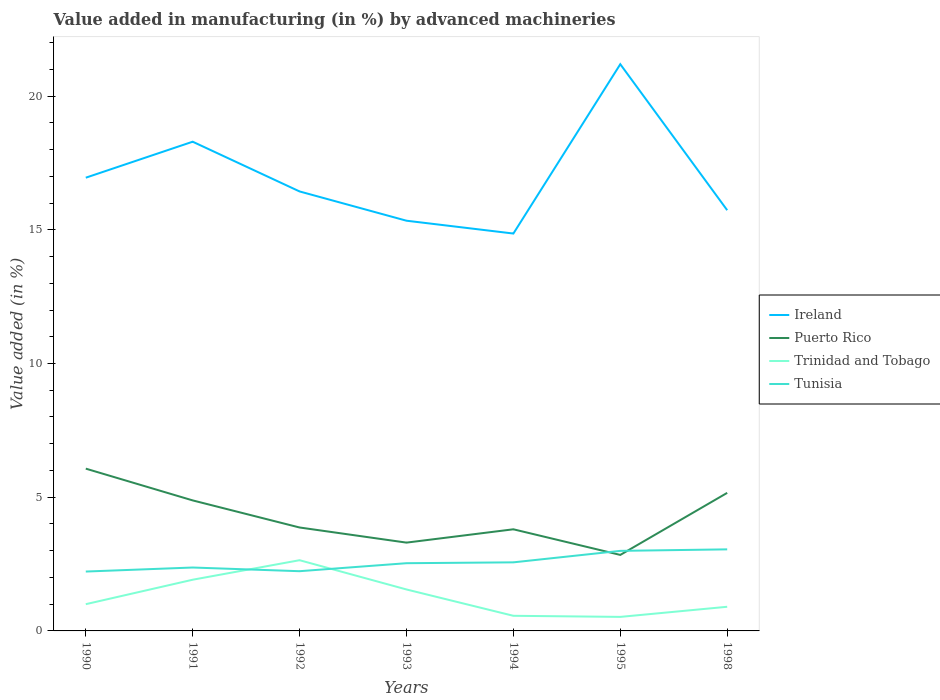Does the line corresponding to Puerto Rico intersect with the line corresponding to Tunisia?
Your response must be concise. Yes. Across all years, what is the maximum percentage of value added in manufacturing by advanced machineries in Trinidad and Tobago?
Offer a very short reply. 0.52. What is the total percentage of value added in manufacturing by advanced machineries in Trinidad and Tobago in the graph?
Your response must be concise. 0.48. What is the difference between the highest and the second highest percentage of value added in manufacturing by advanced machineries in Puerto Rico?
Your answer should be compact. 3.23. Where does the legend appear in the graph?
Your answer should be very brief. Center right. How are the legend labels stacked?
Your answer should be compact. Vertical. What is the title of the graph?
Your response must be concise. Value added in manufacturing (in %) by advanced machineries. Does "Brazil" appear as one of the legend labels in the graph?
Your answer should be compact. No. What is the label or title of the X-axis?
Offer a terse response. Years. What is the label or title of the Y-axis?
Make the answer very short. Value added (in %). What is the Value added (in %) of Ireland in 1990?
Offer a very short reply. 16.95. What is the Value added (in %) of Puerto Rico in 1990?
Make the answer very short. 6.07. What is the Value added (in %) of Trinidad and Tobago in 1990?
Your answer should be very brief. 1. What is the Value added (in %) of Tunisia in 1990?
Give a very brief answer. 2.22. What is the Value added (in %) in Ireland in 1991?
Your answer should be compact. 18.29. What is the Value added (in %) of Puerto Rico in 1991?
Ensure brevity in your answer.  4.88. What is the Value added (in %) in Trinidad and Tobago in 1991?
Keep it short and to the point. 1.91. What is the Value added (in %) in Tunisia in 1991?
Keep it short and to the point. 2.37. What is the Value added (in %) of Ireland in 1992?
Offer a very short reply. 16.43. What is the Value added (in %) of Puerto Rico in 1992?
Offer a terse response. 3.87. What is the Value added (in %) of Trinidad and Tobago in 1992?
Make the answer very short. 2.64. What is the Value added (in %) of Tunisia in 1992?
Your response must be concise. 2.23. What is the Value added (in %) of Ireland in 1993?
Give a very brief answer. 15.34. What is the Value added (in %) in Puerto Rico in 1993?
Ensure brevity in your answer.  3.3. What is the Value added (in %) in Trinidad and Tobago in 1993?
Ensure brevity in your answer.  1.55. What is the Value added (in %) of Tunisia in 1993?
Provide a short and direct response. 2.53. What is the Value added (in %) in Ireland in 1994?
Your response must be concise. 14.86. What is the Value added (in %) of Puerto Rico in 1994?
Your answer should be very brief. 3.8. What is the Value added (in %) in Trinidad and Tobago in 1994?
Provide a succinct answer. 0.57. What is the Value added (in %) in Tunisia in 1994?
Your answer should be very brief. 2.56. What is the Value added (in %) of Ireland in 1995?
Ensure brevity in your answer.  21.19. What is the Value added (in %) of Puerto Rico in 1995?
Keep it short and to the point. 2.84. What is the Value added (in %) in Trinidad and Tobago in 1995?
Keep it short and to the point. 0.52. What is the Value added (in %) in Tunisia in 1995?
Offer a terse response. 2.99. What is the Value added (in %) in Ireland in 1998?
Your response must be concise. 15.73. What is the Value added (in %) of Puerto Rico in 1998?
Give a very brief answer. 5.16. What is the Value added (in %) in Trinidad and Tobago in 1998?
Give a very brief answer. 0.9. What is the Value added (in %) of Tunisia in 1998?
Offer a very short reply. 3.05. Across all years, what is the maximum Value added (in %) in Ireland?
Your response must be concise. 21.19. Across all years, what is the maximum Value added (in %) of Puerto Rico?
Ensure brevity in your answer.  6.07. Across all years, what is the maximum Value added (in %) of Trinidad and Tobago?
Offer a terse response. 2.64. Across all years, what is the maximum Value added (in %) in Tunisia?
Offer a terse response. 3.05. Across all years, what is the minimum Value added (in %) in Ireland?
Ensure brevity in your answer.  14.86. Across all years, what is the minimum Value added (in %) in Puerto Rico?
Your response must be concise. 2.84. Across all years, what is the minimum Value added (in %) in Trinidad and Tobago?
Your answer should be compact. 0.52. Across all years, what is the minimum Value added (in %) of Tunisia?
Offer a terse response. 2.22. What is the total Value added (in %) of Ireland in the graph?
Give a very brief answer. 118.79. What is the total Value added (in %) in Puerto Rico in the graph?
Your answer should be very brief. 29.92. What is the total Value added (in %) in Trinidad and Tobago in the graph?
Ensure brevity in your answer.  9.1. What is the total Value added (in %) in Tunisia in the graph?
Your response must be concise. 17.96. What is the difference between the Value added (in %) of Ireland in 1990 and that in 1991?
Offer a very short reply. -1.35. What is the difference between the Value added (in %) in Puerto Rico in 1990 and that in 1991?
Your answer should be compact. 1.19. What is the difference between the Value added (in %) of Trinidad and Tobago in 1990 and that in 1991?
Keep it short and to the point. -0.91. What is the difference between the Value added (in %) in Tunisia in 1990 and that in 1991?
Give a very brief answer. -0.15. What is the difference between the Value added (in %) of Ireland in 1990 and that in 1992?
Make the answer very short. 0.51. What is the difference between the Value added (in %) in Puerto Rico in 1990 and that in 1992?
Your answer should be compact. 2.2. What is the difference between the Value added (in %) in Trinidad and Tobago in 1990 and that in 1992?
Offer a terse response. -1.64. What is the difference between the Value added (in %) in Tunisia in 1990 and that in 1992?
Give a very brief answer. -0.01. What is the difference between the Value added (in %) in Ireland in 1990 and that in 1993?
Offer a very short reply. 1.61. What is the difference between the Value added (in %) in Puerto Rico in 1990 and that in 1993?
Offer a very short reply. 2.77. What is the difference between the Value added (in %) in Trinidad and Tobago in 1990 and that in 1993?
Provide a short and direct response. -0.55. What is the difference between the Value added (in %) of Tunisia in 1990 and that in 1993?
Offer a terse response. -0.31. What is the difference between the Value added (in %) of Ireland in 1990 and that in 1994?
Give a very brief answer. 2.09. What is the difference between the Value added (in %) in Puerto Rico in 1990 and that in 1994?
Your answer should be compact. 2.27. What is the difference between the Value added (in %) in Trinidad and Tobago in 1990 and that in 1994?
Offer a terse response. 0.43. What is the difference between the Value added (in %) of Tunisia in 1990 and that in 1994?
Offer a terse response. -0.34. What is the difference between the Value added (in %) of Ireland in 1990 and that in 1995?
Give a very brief answer. -4.24. What is the difference between the Value added (in %) of Puerto Rico in 1990 and that in 1995?
Your response must be concise. 3.23. What is the difference between the Value added (in %) of Trinidad and Tobago in 1990 and that in 1995?
Ensure brevity in your answer.  0.48. What is the difference between the Value added (in %) in Tunisia in 1990 and that in 1995?
Give a very brief answer. -0.77. What is the difference between the Value added (in %) of Ireland in 1990 and that in 1998?
Ensure brevity in your answer.  1.22. What is the difference between the Value added (in %) in Puerto Rico in 1990 and that in 1998?
Your response must be concise. 0.91. What is the difference between the Value added (in %) of Trinidad and Tobago in 1990 and that in 1998?
Your answer should be compact. 0.1. What is the difference between the Value added (in %) in Tunisia in 1990 and that in 1998?
Offer a terse response. -0.83. What is the difference between the Value added (in %) in Ireland in 1991 and that in 1992?
Make the answer very short. 1.86. What is the difference between the Value added (in %) in Puerto Rico in 1991 and that in 1992?
Provide a short and direct response. 1.01. What is the difference between the Value added (in %) of Trinidad and Tobago in 1991 and that in 1992?
Provide a short and direct response. -0.73. What is the difference between the Value added (in %) of Tunisia in 1991 and that in 1992?
Provide a short and direct response. 0.14. What is the difference between the Value added (in %) in Ireland in 1991 and that in 1993?
Your answer should be compact. 2.95. What is the difference between the Value added (in %) of Puerto Rico in 1991 and that in 1993?
Keep it short and to the point. 1.58. What is the difference between the Value added (in %) in Trinidad and Tobago in 1991 and that in 1993?
Keep it short and to the point. 0.36. What is the difference between the Value added (in %) of Tunisia in 1991 and that in 1993?
Keep it short and to the point. -0.16. What is the difference between the Value added (in %) of Ireland in 1991 and that in 1994?
Your response must be concise. 3.43. What is the difference between the Value added (in %) in Puerto Rico in 1991 and that in 1994?
Ensure brevity in your answer.  1.08. What is the difference between the Value added (in %) in Trinidad and Tobago in 1991 and that in 1994?
Keep it short and to the point. 1.35. What is the difference between the Value added (in %) of Tunisia in 1991 and that in 1994?
Offer a terse response. -0.19. What is the difference between the Value added (in %) of Ireland in 1991 and that in 1995?
Your response must be concise. -2.9. What is the difference between the Value added (in %) of Puerto Rico in 1991 and that in 1995?
Provide a succinct answer. 2.04. What is the difference between the Value added (in %) in Trinidad and Tobago in 1991 and that in 1995?
Make the answer very short. 1.39. What is the difference between the Value added (in %) in Tunisia in 1991 and that in 1995?
Provide a succinct answer. -0.62. What is the difference between the Value added (in %) in Ireland in 1991 and that in 1998?
Your answer should be compact. 2.56. What is the difference between the Value added (in %) in Puerto Rico in 1991 and that in 1998?
Your answer should be very brief. -0.28. What is the difference between the Value added (in %) in Trinidad and Tobago in 1991 and that in 1998?
Give a very brief answer. 1.01. What is the difference between the Value added (in %) of Tunisia in 1991 and that in 1998?
Provide a succinct answer. -0.68. What is the difference between the Value added (in %) of Ireland in 1992 and that in 1993?
Make the answer very short. 1.09. What is the difference between the Value added (in %) in Puerto Rico in 1992 and that in 1993?
Provide a short and direct response. 0.57. What is the difference between the Value added (in %) in Trinidad and Tobago in 1992 and that in 1993?
Offer a terse response. 1.09. What is the difference between the Value added (in %) of Tunisia in 1992 and that in 1993?
Give a very brief answer. -0.3. What is the difference between the Value added (in %) in Ireland in 1992 and that in 1994?
Your answer should be compact. 1.57. What is the difference between the Value added (in %) of Puerto Rico in 1992 and that in 1994?
Your answer should be compact. 0.07. What is the difference between the Value added (in %) in Trinidad and Tobago in 1992 and that in 1994?
Make the answer very short. 2.08. What is the difference between the Value added (in %) in Tunisia in 1992 and that in 1994?
Offer a terse response. -0.33. What is the difference between the Value added (in %) in Ireland in 1992 and that in 1995?
Ensure brevity in your answer.  -4.76. What is the difference between the Value added (in %) in Puerto Rico in 1992 and that in 1995?
Your response must be concise. 1.03. What is the difference between the Value added (in %) in Trinidad and Tobago in 1992 and that in 1995?
Offer a terse response. 2.12. What is the difference between the Value added (in %) of Tunisia in 1992 and that in 1995?
Offer a very short reply. -0.76. What is the difference between the Value added (in %) in Ireland in 1992 and that in 1998?
Offer a very short reply. 0.7. What is the difference between the Value added (in %) in Puerto Rico in 1992 and that in 1998?
Keep it short and to the point. -1.3. What is the difference between the Value added (in %) in Trinidad and Tobago in 1992 and that in 1998?
Offer a very short reply. 1.74. What is the difference between the Value added (in %) of Tunisia in 1992 and that in 1998?
Make the answer very short. -0.82. What is the difference between the Value added (in %) of Ireland in 1993 and that in 1994?
Provide a short and direct response. 0.48. What is the difference between the Value added (in %) in Puerto Rico in 1993 and that in 1994?
Your response must be concise. -0.5. What is the difference between the Value added (in %) of Trinidad and Tobago in 1993 and that in 1994?
Your answer should be compact. 0.98. What is the difference between the Value added (in %) of Tunisia in 1993 and that in 1994?
Make the answer very short. -0.03. What is the difference between the Value added (in %) of Ireland in 1993 and that in 1995?
Make the answer very short. -5.85. What is the difference between the Value added (in %) of Puerto Rico in 1993 and that in 1995?
Make the answer very short. 0.46. What is the difference between the Value added (in %) in Trinidad and Tobago in 1993 and that in 1995?
Your answer should be very brief. 1.03. What is the difference between the Value added (in %) in Tunisia in 1993 and that in 1995?
Your answer should be very brief. -0.46. What is the difference between the Value added (in %) in Ireland in 1993 and that in 1998?
Give a very brief answer. -0.39. What is the difference between the Value added (in %) of Puerto Rico in 1993 and that in 1998?
Your answer should be compact. -1.86. What is the difference between the Value added (in %) in Trinidad and Tobago in 1993 and that in 1998?
Your response must be concise. 0.65. What is the difference between the Value added (in %) of Tunisia in 1993 and that in 1998?
Provide a short and direct response. -0.52. What is the difference between the Value added (in %) of Ireland in 1994 and that in 1995?
Your answer should be very brief. -6.33. What is the difference between the Value added (in %) of Puerto Rico in 1994 and that in 1995?
Your response must be concise. 0.96. What is the difference between the Value added (in %) of Trinidad and Tobago in 1994 and that in 1995?
Your answer should be compact. 0.04. What is the difference between the Value added (in %) in Tunisia in 1994 and that in 1995?
Offer a terse response. -0.43. What is the difference between the Value added (in %) in Ireland in 1994 and that in 1998?
Give a very brief answer. -0.87. What is the difference between the Value added (in %) in Puerto Rico in 1994 and that in 1998?
Offer a very short reply. -1.36. What is the difference between the Value added (in %) in Trinidad and Tobago in 1994 and that in 1998?
Make the answer very short. -0.34. What is the difference between the Value added (in %) in Tunisia in 1994 and that in 1998?
Your answer should be very brief. -0.49. What is the difference between the Value added (in %) in Ireland in 1995 and that in 1998?
Offer a very short reply. 5.46. What is the difference between the Value added (in %) of Puerto Rico in 1995 and that in 1998?
Ensure brevity in your answer.  -2.32. What is the difference between the Value added (in %) of Trinidad and Tobago in 1995 and that in 1998?
Provide a short and direct response. -0.38. What is the difference between the Value added (in %) of Tunisia in 1995 and that in 1998?
Your answer should be compact. -0.06. What is the difference between the Value added (in %) in Ireland in 1990 and the Value added (in %) in Puerto Rico in 1991?
Offer a very short reply. 12.07. What is the difference between the Value added (in %) of Ireland in 1990 and the Value added (in %) of Trinidad and Tobago in 1991?
Your answer should be very brief. 15.03. What is the difference between the Value added (in %) in Ireland in 1990 and the Value added (in %) in Tunisia in 1991?
Your answer should be very brief. 14.58. What is the difference between the Value added (in %) of Puerto Rico in 1990 and the Value added (in %) of Trinidad and Tobago in 1991?
Offer a terse response. 4.15. What is the difference between the Value added (in %) in Puerto Rico in 1990 and the Value added (in %) in Tunisia in 1991?
Make the answer very short. 3.7. What is the difference between the Value added (in %) in Trinidad and Tobago in 1990 and the Value added (in %) in Tunisia in 1991?
Make the answer very short. -1.37. What is the difference between the Value added (in %) in Ireland in 1990 and the Value added (in %) in Puerto Rico in 1992?
Provide a short and direct response. 13.08. What is the difference between the Value added (in %) in Ireland in 1990 and the Value added (in %) in Trinidad and Tobago in 1992?
Make the answer very short. 14.3. What is the difference between the Value added (in %) of Ireland in 1990 and the Value added (in %) of Tunisia in 1992?
Give a very brief answer. 14.71. What is the difference between the Value added (in %) of Puerto Rico in 1990 and the Value added (in %) of Trinidad and Tobago in 1992?
Your answer should be very brief. 3.42. What is the difference between the Value added (in %) in Puerto Rico in 1990 and the Value added (in %) in Tunisia in 1992?
Your response must be concise. 3.83. What is the difference between the Value added (in %) of Trinidad and Tobago in 1990 and the Value added (in %) of Tunisia in 1992?
Keep it short and to the point. -1.23. What is the difference between the Value added (in %) of Ireland in 1990 and the Value added (in %) of Puerto Rico in 1993?
Your answer should be compact. 13.65. What is the difference between the Value added (in %) of Ireland in 1990 and the Value added (in %) of Trinidad and Tobago in 1993?
Give a very brief answer. 15.4. What is the difference between the Value added (in %) in Ireland in 1990 and the Value added (in %) in Tunisia in 1993?
Keep it short and to the point. 14.42. What is the difference between the Value added (in %) in Puerto Rico in 1990 and the Value added (in %) in Trinidad and Tobago in 1993?
Ensure brevity in your answer.  4.52. What is the difference between the Value added (in %) in Puerto Rico in 1990 and the Value added (in %) in Tunisia in 1993?
Provide a short and direct response. 3.54. What is the difference between the Value added (in %) in Trinidad and Tobago in 1990 and the Value added (in %) in Tunisia in 1993?
Provide a succinct answer. -1.53. What is the difference between the Value added (in %) of Ireland in 1990 and the Value added (in %) of Puerto Rico in 1994?
Give a very brief answer. 13.15. What is the difference between the Value added (in %) in Ireland in 1990 and the Value added (in %) in Trinidad and Tobago in 1994?
Your response must be concise. 16.38. What is the difference between the Value added (in %) of Ireland in 1990 and the Value added (in %) of Tunisia in 1994?
Make the answer very short. 14.38. What is the difference between the Value added (in %) in Puerto Rico in 1990 and the Value added (in %) in Trinidad and Tobago in 1994?
Your answer should be very brief. 5.5. What is the difference between the Value added (in %) of Puerto Rico in 1990 and the Value added (in %) of Tunisia in 1994?
Keep it short and to the point. 3.5. What is the difference between the Value added (in %) in Trinidad and Tobago in 1990 and the Value added (in %) in Tunisia in 1994?
Ensure brevity in your answer.  -1.56. What is the difference between the Value added (in %) in Ireland in 1990 and the Value added (in %) in Puerto Rico in 1995?
Offer a very short reply. 14.11. What is the difference between the Value added (in %) of Ireland in 1990 and the Value added (in %) of Trinidad and Tobago in 1995?
Offer a terse response. 16.42. What is the difference between the Value added (in %) in Ireland in 1990 and the Value added (in %) in Tunisia in 1995?
Your response must be concise. 13.95. What is the difference between the Value added (in %) of Puerto Rico in 1990 and the Value added (in %) of Trinidad and Tobago in 1995?
Your response must be concise. 5.54. What is the difference between the Value added (in %) in Puerto Rico in 1990 and the Value added (in %) in Tunisia in 1995?
Your answer should be compact. 3.07. What is the difference between the Value added (in %) in Trinidad and Tobago in 1990 and the Value added (in %) in Tunisia in 1995?
Provide a short and direct response. -1.99. What is the difference between the Value added (in %) in Ireland in 1990 and the Value added (in %) in Puerto Rico in 1998?
Keep it short and to the point. 11.78. What is the difference between the Value added (in %) of Ireland in 1990 and the Value added (in %) of Trinidad and Tobago in 1998?
Offer a very short reply. 16.04. What is the difference between the Value added (in %) in Ireland in 1990 and the Value added (in %) in Tunisia in 1998?
Give a very brief answer. 13.9. What is the difference between the Value added (in %) in Puerto Rico in 1990 and the Value added (in %) in Trinidad and Tobago in 1998?
Offer a terse response. 5.17. What is the difference between the Value added (in %) of Puerto Rico in 1990 and the Value added (in %) of Tunisia in 1998?
Provide a short and direct response. 3.02. What is the difference between the Value added (in %) of Trinidad and Tobago in 1990 and the Value added (in %) of Tunisia in 1998?
Ensure brevity in your answer.  -2.05. What is the difference between the Value added (in %) of Ireland in 1991 and the Value added (in %) of Puerto Rico in 1992?
Provide a short and direct response. 14.43. What is the difference between the Value added (in %) in Ireland in 1991 and the Value added (in %) in Trinidad and Tobago in 1992?
Keep it short and to the point. 15.65. What is the difference between the Value added (in %) of Ireland in 1991 and the Value added (in %) of Tunisia in 1992?
Ensure brevity in your answer.  16.06. What is the difference between the Value added (in %) of Puerto Rico in 1991 and the Value added (in %) of Trinidad and Tobago in 1992?
Your response must be concise. 2.24. What is the difference between the Value added (in %) of Puerto Rico in 1991 and the Value added (in %) of Tunisia in 1992?
Keep it short and to the point. 2.65. What is the difference between the Value added (in %) of Trinidad and Tobago in 1991 and the Value added (in %) of Tunisia in 1992?
Your response must be concise. -0.32. What is the difference between the Value added (in %) of Ireland in 1991 and the Value added (in %) of Puerto Rico in 1993?
Give a very brief answer. 14.99. What is the difference between the Value added (in %) in Ireland in 1991 and the Value added (in %) in Trinidad and Tobago in 1993?
Offer a terse response. 16.74. What is the difference between the Value added (in %) of Ireland in 1991 and the Value added (in %) of Tunisia in 1993?
Your answer should be compact. 15.76. What is the difference between the Value added (in %) of Puerto Rico in 1991 and the Value added (in %) of Trinidad and Tobago in 1993?
Offer a terse response. 3.33. What is the difference between the Value added (in %) of Puerto Rico in 1991 and the Value added (in %) of Tunisia in 1993?
Make the answer very short. 2.35. What is the difference between the Value added (in %) of Trinidad and Tobago in 1991 and the Value added (in %) of Tunisia in 1993?
Offer a very short reply. -0.62. What is the difference between the Value added (in %) of Ireland in 1991 and the Value added (in %) of Puerto Rico in 1994?
Give a very brief answer. 14.49. What is the difference between the Value added (in %) in Ireland in 1991 and the Value added (in %) in Trinidad and Tobago in 1994?
Provide a short and direct response. 17.73. What is the difference between the Value added (in %) in Ireland in 1991 and the Value added (in %) in Tunisia in 1994?
Your answer should be very brief. 15.73. What is the difference between the Value added (in %) in Puerto Rico in 1991 and the Value added (in %) in Trinidad and Tobago in 1994?
Keep it short and to the point. 4.31. What is the difference between the Value added (in %) of Puerto Rico in 1991 and the Value added (in %) of Tunisia in 1994?
Provide a succinct answer. 2.32. What is the difference between the Value added (in %) in Trinidad and Tobago in 1991 and the Value added (in %) in Tunisia in 1994?
Make the answer very short. -0.65. What is the difference between the Value added (in %) of Ireland in 1991 and the Value added (in %) of Puerto Rico in 1995?
Ensure brevity in your answer.  15.45. What is the difference between the Value added (in %) of Ireland in 1991 and the Value added (in %) of Trinidad and Tobago in 1995?
Provide a succinct answer. 17.77. What is the difference between the Value added (in %) of Ireland in 1991 and the Value added (in %) of Tunisia in 1995?
Your answer should be compact. 15.3. What is the difference between the Value added (in %) of Puerto Rico in 1991 and the Value added (in %) of Trinidad and Tobago in 1995?
Offer a terse response. 4.36. What is the difference between the Value added (in %) of Puerto Rico in 1991 and the Value added (in %) of Tunisia in 1995?
Your answer should be very brief. 1.89. What is the difference between the Value added (in %) in Trinidad and Tobago in 1991 and the Value added (in %) in Tunisia in 1995?
Your answer should be very brief. -1.08. What is the difference between the Value added (in %) of Ireland in 1991 and the Value added (in %) of Puerto Rico in 1998?
Your answer should be very brief. 13.13. What is the difference between the Value added (in %) of Ireland in 1991 and the Value added (in %) of Trinidad and Tobago in 1998?
Provide a short and direct response. 17.39. What is the difference between the Value added (in %) of Ireland in 1991 and the Value added (in %) of Tunisia in 1998?
Make the answer very short. 15.24. What is the difference between the Value added (in %) in Puerto Rico in 1991 and the Value added (in %) in Trinidad and Tobago in 1998?
Provide a succinct answer. 3.98. What is the difference between the Value added (in %) in Puerto Rico in 1991 and the Value added (in %) in Tunisia in 1998?
Ensure brevity in your answer.  1.83. What is the difference between the Value added (in %) in Trinidad and Tobago in 1991 and the Value added (in %) in Tunisia in 1998?
Ensure brevity in your answer.  -1.14. What is the difference between the Value added (in %) in Ireland in 1992 and the Value added (in %) in Puerto Rico in 1993?
Keep it short and to the point. 13.13. What is the difference between the Value added (in %) of Ireland in 1992 and the Value added (in %) of Trinidad and Tobago in 1993?
Your answer should be compact. 14.88. What is the difference between the Value added (in %) in Ireland in 1992 and the Value added (in %) in Tunisia in 1993?
Your response must be concise. 13.9. What is the difference between the Value added (in %) of Puerto Rico in 1992 and the Value added (in %) of Trinidad and Tobago in 1993?
Make the answer very short. 2.32. What is the difference between the Value added (in %) of Puerto Rico in 1992 and the Value added (in %) of Tunisia in 1993?
Give a very brief answer. 1.34. What is the difference between the Value added (in %) in Trinidad and Tobago in 1992 and the Value added (in %) in Tunisia in 1993?
Keep it short and to the point. 0.11. What is the difference between the Value added (in %) in Ireland in 1992 and the Value added (in %) in Puerto Rico in 1994?
Offer a terse response. 12.63. What is the difference between the Value added (in %) in Ireland in 1992 and the Value added (in %) in Trinidad and Tobago in 1994?
Give a very brief answer. 15.87. What is the difference between the Value added (in %) of Ireland in 1992 and the Value added (in %) of Tunisia in 1994?
Your response must be concise. 13.87. What is the difference between the Value added (in %) in Puerto Rico in 1992 and the Value added (in %) in Trinidad and Tobago in 1994?
Your answer should be very brief. 3.3. What is the difference between the Value added (in %) of Puerto Rico in 1992 and the Value added (in %) of Tunisia in 1994?
Make the answer very short. 1.3. What is the difference between the Value added (in %) of Trinidad and Tobago in 1992 and the Value added (in %) of Tunisia in 1994?
Your answer should be compact. 0.08. What is the difference between the Value added (in %) of Ireland in 1992 and the Value added (in %) of Puerto Rico in 1995?
Your response must be concise. 13.59. What is the difference between the Value added (in %) in Ireland in 1992 and the Value added (in %) in Trinidad and Tobago in 1995?
Ensure brevity in your answer.  15.91. What is the difference between the Value added (in %) in Ireland in 1992 and the Value added (in %) in Tunisia in 1995?
Offer a terse response. 13.44. What is the difference between the Value added (in %) of Puerto Rico in 1992 and the Value added (in %) of Trinidad and Tobago in 1995?
Provide a succinct answer. 3.34. What is the difference between the Value added (in %) in Puerto Rico in 1992 and the Value added (in %) in Tunisia in 1995?
Provide a short and direct response. 0.87. What is the difference between the Value added (in %) of Trinidad and Tobago in 1992 and the Value added (in %) of Tunisia in 1995?
Ensure brevity in your answer.  -0.35. What is the difference between the Value added (in %) of Ireland in 1992 and the Value added (in %) of Puerto Rico in 1998?
Make the answer very short. 11.27. What is the difference between the Value added (in %) in Ireland in 1992 and the Value added (in %) in Trinidad and Tobago in 1998?
Give a very brief answer. 15.53. What is the difference between the Value added (in %) of Ireland in 1992 and the Value added (in %) of Tunisia in 1998?
Your answer should be very brief. 13.38. What is the difference between the Value added (in %) in Puerto Rico in 1992 and the Value added (in %) in Trinidad and Tobago in 1998?
Keep it short and to the point. 2.96. What is the difference between the Value added (in %) in Puerto Rico in 1992 and the Value added (in %) in Tunisia in 1998?
Offer a terse response. 0.82. What is the difference between the Value added (in %) of Trinidad and Tobago in 1992 and the Value added (in %) of Tunisia in 1998?
Your answer should be very brief. -0.41. What is the difference between the Value added (in %) in Ireland in 1993 and the Value added (in %) in Puerto Rico in 1994?
Your answer should be very brief. 11.54. What is the difference between the Value added (in %) in Ireland in 1993 and the Value added (in %) in Trinidad and Tobago in 1994?
Provide a short and direct response. 14.77. What is the difference between the Value added (in %) of Ireland in 1993 and the Value added (in %) of Tunisia in 1994?
Offer a very short reply. 12.77. What is the difference between the Value added (in %) in Puerto Rico in 1993 and the Value added (in %) in Trinidad and Tobago in 1994?
Offer a very short reply. 2.74. What is the difference between the Value added (in %) of Puerto Rico in 1993 and the Value added (in %) of Tunisia in 1994?
Provide a succinct answer. 0.74. What is the difference between the Value added (in %) in Trinidad and Tobago in 1993 and the Value added (in %) in Tunisia in 1994?
Offer a terse response. -1.01. What is the difference between the Value added (in %) in Ireland in 1993 and the Value added (in %) in Puerto Rico in 1995?
Offer a terse response. 12.5. What is the difference between the Value added (in %) of Ireland in 1993 and the Value added (in %) of Trinidad and Tobago in 1995?
Provide a succinct answer. 14.81. What is the difference between the Value added (in %) in Ireland in 1993 and the Value added (in %) in Tunisia in 1995?
Your answer should be very brief. 12.35. What is the difference between the Value added (in %) in Puerto Rico in 1993 and the Value added (in %) in Trinidad and Tobago in 1995?
Provide a short and direct response. 2.78. What is the difference between the Value added (in %) in Puerto Rico in 1993 and the Value added (in %) in Tunisia in 1995?
Your response must be concise. 0.31. What is the difference between the Value added (in %) of Trinidad and Tobago in 1993 and the Value added (in %) of Tunisia in 1995?
Keep it short and to the point. -1.44. What is the difference between the Value added (in %) in Ireland in 1993 and the Value added (in %) in Puerto Rico in 1998?
Offer a terse response. 10.18. What is the difference between the Value added (in %) in Ireland in 1993 and the Value added (in %) in Trinidad and Tobago in 1998?
Provide a succinct answer. 14.44. What is the difference between the Value added (in %) of Ireland in 1993 and the Value added (in %) of Tunisia in 1998?
Keep it short and to the point. 12.29. What is the difference between the Value added (in %) of Puerto Rico in 1993 and the Value added (in %) of Trinidad and Tobago in 1998?
Your answer should be compact. 2.4. What is the difference between the Value added (in %) in Puerto Rico in 1993 and the Value added (in %) in Tunisia in 1998?
Offer a terse response. 0.25. What is the difference between the Value added (in %) of Trinidad and Tobago in 1993 and the Value added (in %) of Tunisia in 1998?
Give a very brief answer. -1.5. What is the difference between the Value added (in %) of Ireland in 1994 and the Value added (in %) of Puerto Rico in 1995?
Provide a short and direct response. 12.02. What is the difference between the Value added (in %) in Ireland in 1994 and the Value added (in %) in Trinidad and Tobago in 1995?
Offer a very short reply. 14.33. What is the difference between the Value added (in %) of Ireland in 1994 and the Value added (in %) of Tunisia in 1995?
Offer a terse response. 11.87. What is the difference between the Value added (in %) of Puerto Rico in 1994 and the Value added (in %) of Trinidad and Tobago in 1995?
Offer a terse response. 3.28. What is the difference between the Value added (in %) of Puerto Rico in 1994 and the Value added (in %) of Tunisia in 1995?
Give a very brief answer. 0.81. What is the difference between the Value added (in %) of Trinidad and Tobago in 1994 and the Value added (in %) of Tunisia in 1995?
Your answer should be compact. -2.43. What is the difference between the Value added (in %) in Ireland in 1994 and the Value added (in %) in Puerto Rico in 1998?
Keep it short and to the point. 9.7. What is the difference between the Value added (in %) of Ireland in 1994 and the Value added (in %) of Trinidad and Tobago in 1998?
Offer a terse response. 13.96. What is the difference between the Value added (in %) in Ireland in 1994 and the Value added (in %) in Tunisia in 1998?
Offer a very short reply. 11.81. What is the difference between the Value added (in %) of Puerto Rico in 1994 and the Value added (in %) of Trinidad and Tobago in 1998?
Make the answer very short. 2.9. What is the difference between the Value added (in %) of Puerto Rico in 1994 and the Value added (in %) of Tunisia in 1998?
Make the answer very short. 0.75. What is the difference between the Value added (in %) in Trinidad and Tobago in 1994 and the Value added (in %) in Tunisia in 1998?
Keep it short and to the point. -2.48. What is the difference between the Value added (in %) in Ireland in 1995 and the Value added (in %) in Puerto Rico in 1998?
Your response must be concise. 16.03. What is the difference between the Value added (in %) of Ireland in 1995 and the Value added (in %) of Trinidad and Tobago in 1998?
Provide a succinct answer. 20.29. What is the difference between the Value added (in %) in Ireland in 1995 and the Value added (in %) in Tunisia in 1998?
Offer a terse response. 18.14. What is the difference between the Value added (in %) in Puerto Rico in 1995 and the Value added (in %) in Trinidad and Tobago in 1998?
Your answer should be very brief. 1.94. What is the difference between the Value added (in %) of Puerto Rico in 1995 and the Value added (in %) of Tunisia in 1998?
Your answer should be very brief. -0.21. What is the difference between the Value added (in %) in Trinidad and Tobago in 1995 and the Value added (in %) in Tunisia in 1998?
Ensure brevity in your answer.  -2.53. What is the average Value added (in %) of Ireland per year?
Give a very brief answer. 16.97. What is the average Value added (in %) of Puerto Rico per year?
Provide a short and direct response. 4.27. What is the average Value added (in %) in Trinidad and Tobago per year?
Provide a short and direct response. 1.3. What is the average Value added (in %) in Tunisia per year?
Your response must be concise. 2.57. In the year 1990, what is the difference between the Value added (in %) of Ireland and Value added (in %) of Puerto Rico?
Make the answer very short. 10.88. In the year 1990, what is the difference between the Value added (in %) in Ireland and Value added (in %) in Trinidad and Tobago?
Offer a terse response. 15.95. In the year 1990, what is the difference between the Value added (in %) of Ireland and Value added (in %) of Tunisia?
Your answer should be compact. 14.73. In the year 1990, what is the difference between the Value added (in %) in Puerto Rico and Value added (in %) in Trinidad and Tobago?
Provide a short and direct response. 5.07. In the year 1990, what is the difference between the Value added (in %) in Puerto Rico and Value added (in %) in Tunisia?
Provide a succinct answer. 3.85. In the year 1990, what is the difference between the Value added (in %) in Trinidad and Tobago and Value added (in %) in Tunisia?
Ensure brevity in your answer.  -1.22. In the year 1991, what is the difference between the Value added (in %) of Ireland and Value added (in %) of Puerto Rico?
Your answer should be very brief. 13.41. In the year 1991, what is the difference between the Value added (in %) of Ireland and Value added (in %) of Trinidad and Tobago?
Your answer should be very brief. 16.38. In the year 1991, what is the difference between the Value added (in %) in Ireland and Value added (in %) in Tunisia?
Provide a short and direct response. 15.92. In the year 1991, what is the difference between the Value added (in %) in Puerto Rico and Value added (in %) in Trinidad and Tobago?
Ensure brevity in your answer.  2.97. In the year 1991, what is the difference between the Value added (in %) in Puerto Rico and Value added (in %) in Tunisia?
Provide a short and direct response. 2.51. In the year 1991, what is the difference between the Value added (in %) in Trinidad and Tobago and Value added (in %) in Tunisia?
Your answer should be compact. -0.46. In the year 1992, what is the difference between the Value added (in %) in Ireland and Value added (in %) in Puerto Rico?
Keep it short and to the point. 12.57. In the year 1992, what is the difference between the Value added (in %) in Ireland and Value added (in %) in Trinidad and Tobago?
Provide a succinct answer. 13.79. In the year 1992, what is the difference between the Value added (in %) of Ireland and Value added (in %) of Tunisia?
Offer a very short reply. 14.2. In the year 1992, what is the difference between the Value added (in %) of Puerto Rico and Value added (in %) of Trinidad and Tobago?
Provide a short and direct response. 1.22. In the year 1992, what is the difference between the Value added (in %) of Puerto Rico and Value added (in %) of Tunisia?
Provide a short and direct response. 1.63. In the year 1992, what is the difference between the Value added (in %) of Trinidad and Tobago and Value added (in %) of Tunisia?
Offer a terse response. 0.41. In the year 1993, what is the difference between the Value added (in %) in Ireland and Value added (in %) in Puerto Rico?
Your answer should be very brief. 12.04. In the year 1993, what is the difference between the Value added (in %) of Ireland and Value added (in %) of Trinidad and Tobago?
Provide a short and direct response. 13.79. In the year 1993, what is the difference between the Value added (in %) of Ireland and Value added (in %) of Tunisia?
Give a very brief answer. 12.81. In the year 1993, what is the difference between the Value added (in %) of Puerto Rico and Value added (in %) of Trinidad and Tobago?
Make the answer very short. 1.75. In the year 1993, what is the difference between the Value added (in %) in Puerto Rico and Value added (in %) in Tunisia?
Make the answer very short. 0.77. In the year 1993, what is the difference between the Value added (in %) of Trinidad and Tobago and Value added (in %) of Tunisia?
Provide a succinct answer. -0.98. In the year 1994, what is the difference between the Value added (in %) of Ireland and Value added (in %) of Puerto Rico?
Offer a very short reply. 11.06. In the year 1994, what is the difference between the Value added (in %) in Ireland and Value added (in %) in Trinidad and Tobago?
Provide a short and direct response. 14.29. In the year 1994, what is the difference between the Value added (in %) in Ireland and Value added (in %) in Tunisia?
Offer a terse response. 12.29. In the year 1994, what is the difference between the Value added (in %) in Puerto Rico and Value added (in %) in Trinidad and Tobago?
Your answer should be compact. 3.23. In the year 1994, what is the difference between the Value added (in %) of Puerto Rico and Value added (in %) of Tunisia?
Provide a succinct answer. 1.24. In the year 1994, what is the difference between the Value added (in %) in Trinidad and Tobago and Value added (in %) in Tunisia?
Your response must be concise. -2. In the year 1995, what is the difference between the Value added (in %) of Ireland and Value added (in %) of Puerto Rico?
Your response must be concise. 18.35. In the year 1995, what is the difference between the Value added (in %) of Ireland and Value added (in %) of Trinidad and Tobago?
Your answer should be compact. 20.67. In the year 1995, what is the difference between the Value added (in %) in Ireland and Value added (in %) in Tunisia?
Your response must be concise. 18.2. In the year 1995, what is the difference between the Value added (in %) of Puerto Rico and Value added (in %) of Trinidad and Tobago?
Offer a very short reply. 2.32. In the year 1995, what is the difference between the Value added (in %) in Puerto Rico and Value added (in %) in Tunisia?
Your answer should be compact. -0.15. In the year 1995, what is the difference between the Value added (in %) of Trinidad and Tobago and Value added (in %) of Tunisia?
Give a very brief answer. -2.47. In the year 1998, what is the difference between the Value added (in %) in Ireland and Value added (in %) in Puerto Rico?
Make the answer very short. 10.57. In the year 1998, what is the difference between the Value added (in %) in Ireland and Value added (in %) in Trinidad and Tobago?
Give a very brief answer. 14.83. In the year 1998, what is the difference between the Value added (in %) of Ireland and Value added (in %) of Tunisia?
Your answer should be compact. 12.68. In the year 1998, what is the difference between the Value added (in %) of Puerto Rico and Value added (in %) of Trinidad and Tobago?
Make the answer very short. 4.26. In the year 1998, what is the difference between the Value added (in %) of Puerto Rico and Value added (in %) of Tunisia?
Ensure brevity in your answer.  2.11. In the year 1998, what is the difference between the Value added (in %) of Trinidad and Tobago and Value added (in %) of Tunisia?
Your answer should be very brief. -2.15. What is the ratio of the Value added (in %) in Ireland in 1990 to that in 1991?
Your answer should be very brief. 0.93. What is the ratio of the Value added (in %) in Puerto Rico in 1990 to that in 1991?
Your response must be concise. 1.24. What is the ratio of the Value added (in %) of Trinidad and Tobago in 1990 to that in 1991?
Make the answer very short. 0.52. What is the ratio of the Value added (in %) in Tunisia in 1990 to that in 1991?
Your response must be concise. 0.94. What is the ratio of the Value added (in %) of Ireland in 1990 to that in 1992?
Provide a short and direct response. 1.03. What is the ratio of the Value added (in %) in Puerto Rico in 1990 to that in 1992?
Your answer should be compact. 1.57. What is the ratio of the Value added (in %) in Trinidad and Tobago in 1990 to that in 1992?
Your answer should be compact. 0.38. What is the ratio of the Value added (in %) in Tunisia in 1990 to that in 1992?
Give a very brief answer. 0.99. What is the ratio of the Value added (in %) of Ireland in 1990 to that in 1993?
Keep it short and to the point. 1.1. What is the ratio of the Value added (in %) in Puerto Rico in 1990 to that in 1993?
Provide a short and direct response. 1.84. What is the ratio of the Value added (in %) of Trinidad and Tobago in 1990 to that in 1993?
Offer a very short reply. 0.65. What is the ratio of the Value added (in %) in Tunisia in 1990 to that in 1993?
Ensure brevity in your answer.  0.88. What is the ratio of the Value added (in %) in Ireland in 1990 to that in 1994?
Give a very brief answer. 1.14. What is the ratio of the Value added (in %) of Puerto Rico in 1990 to that in 1994?
Offer a terse response. 1.6. What is the ratio of the Value added (in %) in Trinidad and Tobago in 1990 to that in 1994?
Your answer should be compact. 1.77. What is the ratio of the Value added (in %) of Tunisia in 1990 to that in 1994?
Offer a terse response. 0.87. What is the ratio of the Value added (in %) of Ireland in 1990 to that in 1995?
Your answer should be very brief. 0.8. What is the ratio of the Value added (in %) of Puerto Rico in 1990 to that in 1995?
Provide a succinct answer. 2.14. What is the ratio of the Value added (in %) in Trinidad and Tobago in 1990 to that in 1995?
Offer a very short reply. 1.91. What is the ratio of the Value added (in %) in Tunisia in 1990 to that in 1995?
Your answer should be compact. 0.74. What is the ratio of the Value added (in %) in Ireland in 1990 to that in 1998?
Your response must be concise. 1.08. What is the ratio of the Value added (in %) in Puerto Rico in 1990 to that in 1998?
Your answer should be very brief. 1.18. What is the ratio of the Value added (in %) in Trinidad and Tobago in 1990 to that in 1998?
Your answer should be compact. 1.11. What is the ratio of the Value added (in %) in Tunisia in 1990 to that in 1998?
Your answer should be very brief. 0.73. What is the ratio of the Value added (in %) of Ireland in 1991 to that in 1992?
Offer a very short reply. 1.11. What is the ratio of the Value added (in %) in Puerto Rico in 1991 to that in 1992?
Your answer should be compact. 1.26. What is the ratio of the Value added (in %) of Trinidad and Tobago in 1991 to that in 1992?
Make the answer very short. 0.72. What is the ratio of the Value added (in %) of Tunisia in 1991 to that in 1992?
Ensure brevity in your answer.  1.06. What is the ratio of the Value added (in %) of Ireland in 1991 to that in 1993?
Provide a succinct answer. 1.19. What is the ratio of the Value added (in %) in Puerto Rico in 1991 to that in 1993?
Your answer should be very brief. 1.48. What is the ratio of the Value added (in %) in Trinidad and Tobago in 1991 to that in 1993?
Keep it short and to the point. 1.23. What is the ratio of the Value added (in %) of Tunisia in 1991 to that in 1993?
Keep it short and to the point. 0.94. What is the ratio of the Value added (in %) in Ireland in 1991 to that in 1994?
Offer a very short reply. 1.23. What is the ratio of the Value added (in %) in Puerto Rico in 1991 to that in 1994?
Your response must be concise. 1.28. What is the ratio of the Value added (in %) of Trinidad and Tobago in 1991 to that in 1994?
Your answer should be compact. 3.39. What is the ratio of the Value added (in %) of Tunisia in 1991 to that in 1994?
Make the answer very short. 0.92. What is the ratio of the Value added (in %) in Ireland in 1991 to that in 1995?
Offer a terse response. 0.86. What is the ratio of the Value added (in %) of Puerto Rico in 1991 to that in 1995?
Offer a terse response. 1.72. What is the ratio of the Value added (in %) in Trinidad and Tobago in 1991 to that in 1995?
Your response must be concise. 3.65. What is the ratio of the Value added (in %) of Tunisia in 1991 to that in 1995?
Your answer should be very brief. 0.79. What is the ratio of the Value added (in %) of Ireland in 1991 to that in 1998?
Offer a terse response. 1.16. What is the ratio of the Value added (in %) in Puerto Rico in 1991 to that in 1998?
Offer a terse response. 0.95. What is the ratio of the Value added (in %) of Trinidad and Tobago in 1991 to that in 1998?
Your answer should be compact. 2.12. What is the ratio of the Value added (in %) in Tunisia in 1991 to that in 1998?
Make the answer very short. 0.78. What is the ratio of the Value added (in %) in Ireland in 1992 to that in 1993?
Your answer should be compact. 1.07. What is the ratio of the Value added (in %) of Puerto Rico in 1992 to that in 1993?
Your answer should be compact. 1.17. What is the ratio of the Value added (in %) in Trinidad and Tobago in 1992 to that in 1993?
Ensure brevity in your answer.  1.71. What is the ratio of the Value added (in %) of Tunisia in 1992 to that in 1993?
Provide a short and direct response. 0.88. What is the ratio of the Value added (in %) in Ireland in 1992 to that in 1994?
Offer a terse response. 1.11. What is the ratio of the Value added (in %) of Puerto Rico in 1992 to that in 1994?
Keep it short and to the point. 1.02. What is the ratio of the Value added (in %) in Trinidad and Tobago in 1992 to that in 1994?
Give a very brief answer. 4.68. What is the ratio of the Value added (in %) in Tunisia in 1992 to that in 1994?
Keep it short and to the point. 0.87. What is the ratio of the Value added (in %) of Ireland in 1992 to that in 1995?
Offer a very short reply. 0.78. What is the ratio of the Value added (in %) in Puerto Rico in 1992 to that in 1995?
Ensure brevity in your answer.  1.36. What is the ratio of the Value added (in %) of Trinidad and Tobago in 1992 to that in 1995?
Your answer should be compact. 5.04. What is the ratio of the Value added (in %) in Tunisia in 1992 to that in 1995?
Provide a short and direct response. 0.75. What is the ratio of the Value added (in %) in Ireland in 1992 to that in 1998?
Provide a short and direct response. 1.04. What is the ratio of the Value added (in %) of Puerto Rico in 1992 to that in 1998?
Keep it short and to the point. 0.75. What is the ratio of the Value added (in %) in Trinidad and Tobago in 1992 to that in 1998?
Make the answer very short. 2.93. What is the ratio of the Value added (in %) in Tunisia in 1992 to that in 1998?
Provide a succinct answer. 0.73. What is the ratio of the Value added (in %) in Ireland in 1993 to that in 1994?
Your answer should be very brief. 1.03. What is the ratio of the Value added (in %) of Puerto Rico in 1993 to that in 1994?
Make the answer very short. 0.87. What is the ratio of the Value added (in %) of Trinidad and Tobago in 1993 to that in 1994?
Your response must be concise. 2.74. What is the ratio of the Value added (in %) of Tunisia in 1993 to that in 1994?
Keep it short and to the point. 0.99. What is the ratio of the Value added (in %) in Ireland in 1993 to that in 1995?
Offer a very short reply. 0.72. What is the ratio of the Value added (in %) in Puerto Rico in 1993 to that in 1995?
Give a very brief answer. 1.16. What is the ratio of the Value added (in %) in Trinidad and Tobago in 1993 to that in 1995?
Offer a very short reply. 2.95. What is the ratio of the Value added (in %) of Tunisia in 1993 to that in 1995?
Your response must be concise. 0.85. What is the ratio of the Value added (in %) of Ireland in 1993 to that in 1998?
Provide a succinct answer. 0.97. What is the ratio of the Value added (in %) of Puerto Rico in 1993 to that in 1998?
Ensure brevity in your answer.  0.64. What is the ratio of the Value added (in %) of Trinidad and Tobago in 1993 to that in 1998?
Offer a very short reply. 1.72. What is the ratio of the Value added (in %) of Tunisia in 1993 to that in 1998?
Ensure brevity in your answer.  0.83. What is the ratio of the Value added (in %) in Ireland in 1994 to that in 1995?
Offer a very short reply. 0.7. What is the ratio of the Value added (in %) of Puerto Rico in 1994 to that in 1995?
Provide a short and direct response. 1.34. What is the ratio of the Value added (in %) in Trinidad and Tobago in 1994 to that in 1995?
Provide a succinct answer. 1.08. What is the ratio of the Value added (in %) in Tunisia in 1994 to that in 1995?
Your answer should be compact. 0.86. What is the ratio of the Value added (in %) in Ireland in 1994 to that in 1998?
Your answer should be very brief. 0.94. What is the ratio of the Value added (in %) of Puerto Rico in 1994 to that in 1998?
Make the answer very short. 0.74. What is the ratio of the Value added (in %) in Trinidad and Tobago in 1994 to that in 1998?
Provide a short and direct response. 0.63. What is the ratio of the Value added (in %) in Tunisia in 1994 to that in 1998?
Offer a very short reply. 0.84. What is the ratio of the Value added (in %) of Ireland in 1995 to that in 1998?
Offer a very short reply. 1.35. What is the ratio of the Value added (in %) in Puerto Rico in 1995 to that in 1998?
Provide a succinct answer. 0.55. What is the ratio of the Value added (in %) of Trinidad and Tobago in 1995 to that in 1998?
Provide a short and direct response. 0.58. What is the ratio of the Value added (in %) of Tunisia in 1995 to that in 1998?
Offer a terse response. 0.98. What is the difference between the highest and the second highest Value added (in %) in Ireland?
Provide a succinct answer. 2.9. What is the difference between the highest and the second highest Value added (in %) in Puerto Rico?
Your answer should be very brief. 0.91. What is the difference between the highest and the second highest Value added (in %) in Trinidad and Tobago?
Your answer should be compact. 0.73. What is the difference between the highest and the second highest Value added (in %) of Tunisia?
Provide a short and direct response. 0.06. What is the difference between the highest and the lowest Value added (in %) in Ireland?
Make the answer very short. 6.33. What is the difference between the highest and the lowest Value added (in %) of Puerto Rico?
Your answer should be compact. 3.23. What is the difference between the highest and the lowest Value added (in %) in Trinidad and Tobago?
Make the answer very short. 2.12. What is the difference between the highest and the lowest Value added (in %) in Tunisia?
Offer a very short reply. 0.83. 